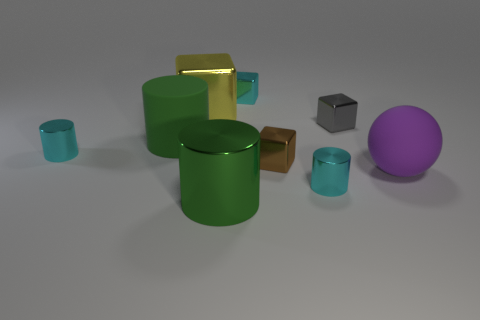How many things are either blocks that are in front of the large yellow block or yellow shiny things? There is one block in front of the large yellow block, which is a small gray block. In addition, there are two yellow shiny things; the large yellow block itself and a yellow cylinder. Summing up, there are three items that fit the criteria. 